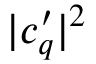<formula> <loc_0><loc_0><loc_500><loc_500>| c _ { q } ^ { \prime } | ^ { 2 }</formula> 